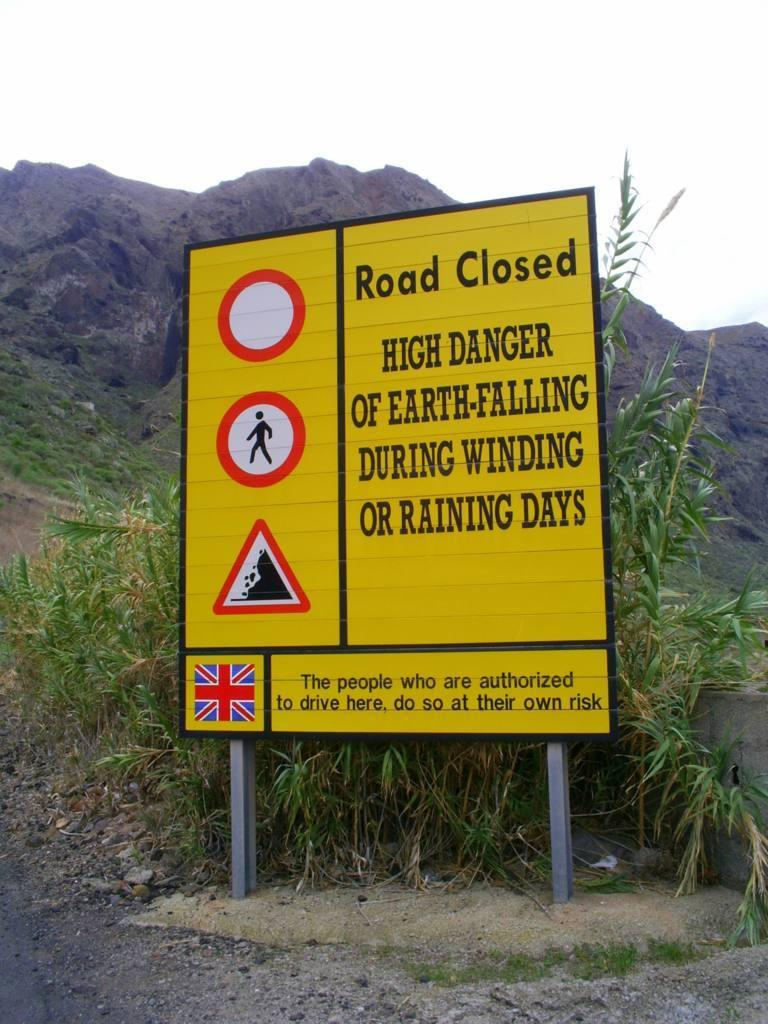<image>
Render a clear and concise summary of the photo. A road closed sign denotes falling earth and driving at your own risk. 